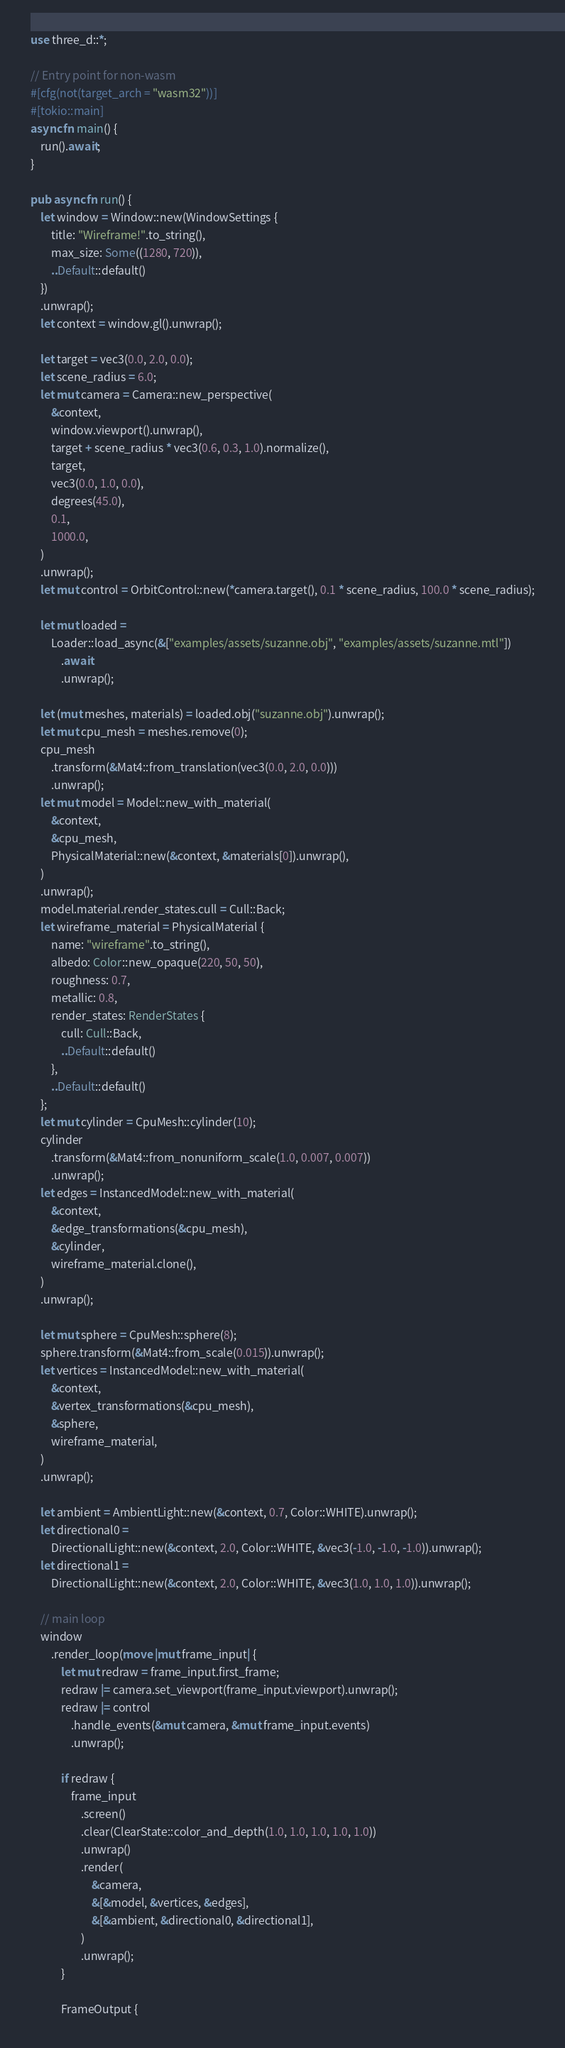Convert code to text. <code><loc_0><loc_0><loc_500><loc_500><_Rust_>use three_d::*;

// Entry point for non-wasm
#[cfg(not(target_arch = "wasm32"))]
#[tokio::main]
async fn main() {
    run().await;
}

pub async fn run() {
    let window = Window::new(WindowSettings {
        title: "Wireframe!".to_string(),
        max_size: Some((1280, 720)),
        ..Default::default()
    })
    .unwrap();
    let context = window.gl().unwrap();

    let target = vec3(0.0, 2.0, 0.0);
    let scene_radius = 6.0;
    let mut camera = Camera::new_perspective(
        &context,
        window.viewport().unwrap(),
        target + scene_radius * vec3(0.6, 0.3, 1.0).normalize(),
        target,
        vec3(0.0, 1.0, 0.0),
        degrees(45.0),
        0.1,
        1000.0,
    )
    .unwrap();
    let mut control = OrbitControl::new(*camera.target(), 0.1 * scene_radius, 100.0 * scene_radius);

    let mut loaded =
        Loader::load_async(&["examples/assets/suzanne.obj", "examples/assets/suzanne.mtl"])
            .await
            .unwrap();

    let (mut meshes, materials) = loaded.obj("suzanne.obj").unwrap();
    let mut cpu_mesh = meshes.remove(0);
    cpu_mesh
        .transform(&Mat4::from_translation(vec3(0.0, 2.0, 0.0)))
        .unwrap();
    let mut model = Model::new_with_material(
        &context,
        &cpu_mesh,
        PhysicalMaterial::new(&context, &materials[0]).unwrap(),
    )
    .unwrap();
    model.material.render_states.cull = Cull::Back;
    let wireframe_material = PhysicalMaterial {
        name: "wireframe".to_string(),
        albedo: Color::new_opaque(220, 50, 50),
        roughness: 0.7,
        metallic: 0.8,
        render_states: RenderStates {
            cull: Cull::Back,
            ..Default::default()
        },
        ..Default::default()
    };
    let mut cylinder = CpuMesh::cylinder(10);
    cylinder
        .transform(&Mat4::from_nonuniform_scale(1.0, 0.007, 0.007))
        .unwrap();
    let edges = InstancedModel::new_with_material(
        &context,
        &edge_transformations(&cpu_mesh),
        &cylinder,
        wireframe_material.clone(),
    )
    .unwrap();

    let mut sphere = CpuMesh::sphere(8);
    sphere.transform(&Mat4::from_scale(0.015)).unwrap();
    let vertices = InstancedModel::new_with_material(
        &context,
        &vertex_transformations(&cpu_mesh),
        &sphere,
        wireframe_material,
    )
    .unwrap();

    let ambient = AmbientLight::new(&context, 0.7, Color::WHITE).unwrap();
    let directional0 =
        DirectionalLight::new(&context, 2.0, Color::WHITE, &vec3(-1.0, -1.0, -1.0)).unwrap();
    let directional1 =
        DirectionalLight::new(&context, 2.0, Color::WHITE, &vec3(1.0, 1.0, 1.0)).unwrap();

    // main loop
    window
        .render_loop(move |mut frame_input| {
            let mut redraw = frame_input.first_frame;
            redraw |= camera.set_viewport(frame_input.viewport).unwrap();
            redraw |= control
                .handle_events(&mut camera, &mut frame_input.events)
                .unwrap();

            if redraw {
                frame_input
                    .screen()
                    .clear(ClearState::color_and_depth(1.0, 1.0, 1.0, 1.0, 1.0))
                    .unwrap()
                    .render(
                        &camera,
                        &[&model, &vertices, &edges],
                        &[&ambient, &directional0, &directional1],
                    )
                    .unwrap();
            }

            FrameOutput {</code> 